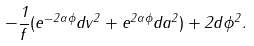<formula> <loc_0><loc_0><loc_500><loc_500>- \frac { 1 } { f } ( e ^ { - 2 \alpha \phi } d v ^ { 2 } + e ^ { 2 \alpha \phi } d a ^ { 2 } ) + 2 d \phi ^ { 2 } .</formula> 